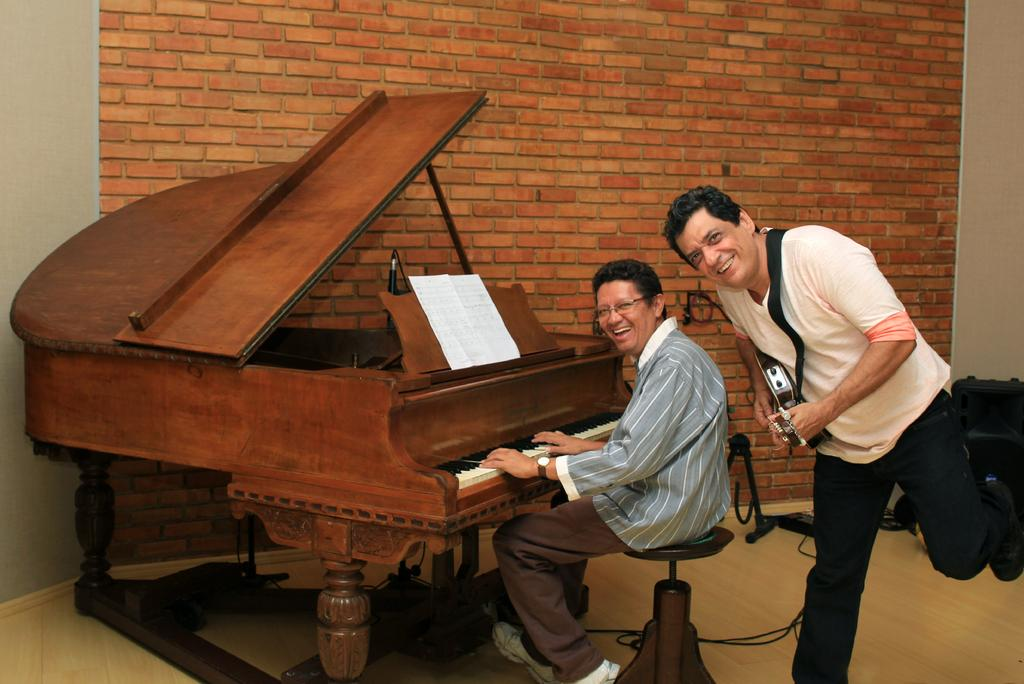What is the seated man doing in the image? The seated man is playing a violin in the image. What is the standing man doing in the image? The standing man is playing a guitar in the image. Can you describe the position of the standing man's hand? The standing man's hand is visible in the image. What type of cup is being used to play the violin in the image? There is no cup present in the image, and the violin is being played with a bow, not a cup. Can you see any goldfish swimming in the image? There are no goldfish present in the image; it features two men playing musical instruments. 